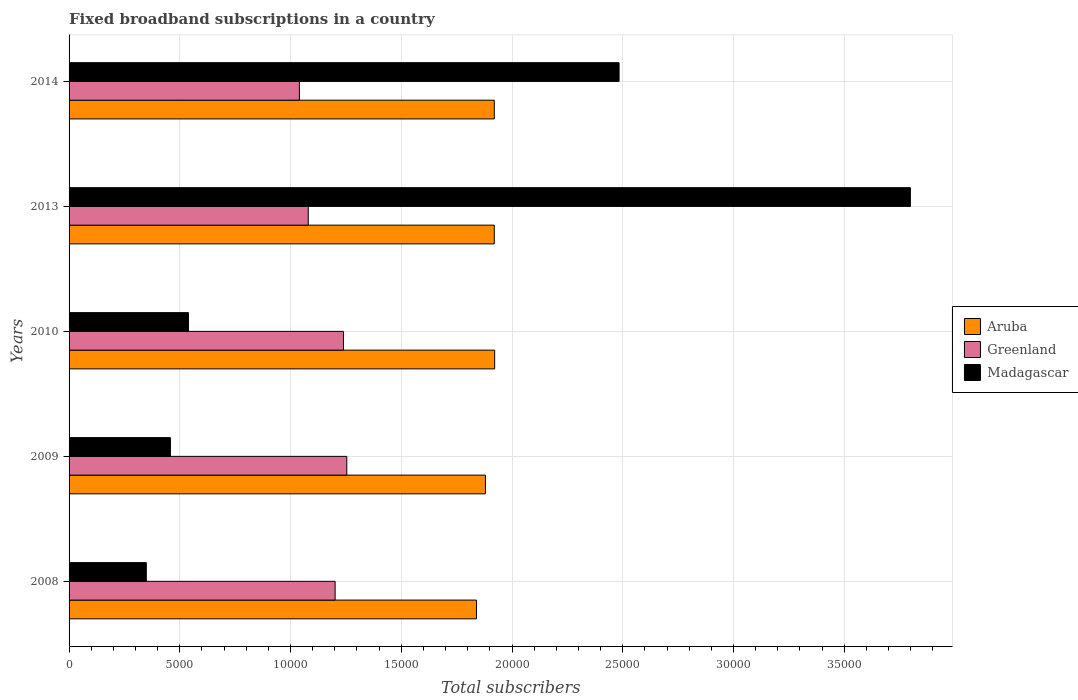Are the number of bars per tick equal to the number of legend labels?
Give a very brief answer. Yes. How many bars are there on the 5th tick from the top?
Provide a succinct answer. 3. How many bars are there on the 2nd tick from the bottom?
Your response must be concise. 3. In how many cases, is the number of bars for a given year not equal to the number of legend labels?
Keep it short and to the point. 0. What is the number of broadband subscriptions in Greenland in 2013?
Offer a very short reply. 1.08e+04. Across all years, what is the maximum number of broadband subscriptions in Madagascar?
Ensure brevity in your answer.  3.80e+04. Across all years, what is the minimum number of broadband subscriptions in Greenland?
Make the answer very short. 1.04e+04. In which year was the number of broadband subscriptions in Greenland maximum?
Your response must be concise. 2009. What is the total number of broadband subscriptions in Greenland in the graph?
Offer a very short reply. 5.81e+04. What is the difference between the number of broadband subscriptions in Madagascar in 2008 and that in 2014?
Your response must be concise. -2.13e+04. What is the difference between the number of broadband subscriptions in Greenland in 2009 and the number of broadband subscriptions in Aruba in 2013?
Offer a very short reply. -6660. What is the average number of broadband subscriptions in Madagascar per year?
Provide a short and direct response. 1.53e+04. In the year 2010, what is the difference between the number of broadband subscriptions in Madagascar and number of broadband subscriptions in Aruba?
Give a very brief answer. -1.38e+04. In how many years, is the number of broadband subscriptions in Aruba greater than 15000 ?
Keep it short and to the point. 5. What is the ratio of the number of broadband subscriptions in Greenland in 2009 to that in 2010?
Offer a very short reply. 1.01. Is the number of broadband subscriptions in Aruba in 2008 less than that in 2013?
Your response must be concise. Yes. Is the difference between the number of broadband subscriptions in Madagascar in 2008 and 2009 greater than the difference between the number of broadband subscriptions in Aruba in 2008 and 2009?
Make the answer very short. No. What is the difference between the highest and the second highest number of broadband subscriptions in Aruba?
Your answer should be very brief. 17. What is the difference between the highest and the lowest number of broadband subscriptions in Greenland?
Give a very brief answer. 2140. In how many years, is the number of broadband subscriptions in Greenland greater than the average number of broadband subscriptions in Greenland taken over all years?
Ensure brevity in your answer.  3. What does the 3rd bar from the top in 2009 represents?
Give a very brief answer. Aruba. What does the 3rd bar from the bottom in 2008 represents?
Provide a succinct answer. Madagascar. How many bars are there?
Provide a short and direct response. 15. Are all the bars in the graph horizontal?
Provide a succinct answer. Yes. How many years are there in the graph?
Offer a terse response. 5. Are the values on the major ticks of X-axis written in scientific E-notation?
Make the answer very short. No. Does the graph contain any zero values?
Your response must be concise. No. How many legend labels are there?
Your answer should be very brief. 3. What is the title of the graph?
Ensure brevity in your answer.  Fixed broadband subscriptions in a country. Does "Moldova" appear as one of the legend labels in the graph?
Ensure brevity in your answer.  No. What is the label or title of the X-axis?
Make the answer very short. Total subscribers. What is the Total subscribers of Aruba in 2008?
Make the answer very short. 1.84e+04. What is the Total subscribers of Greenland in 2008?
Ensure brevity in your answer.  1.20e+04. What is the Total subscribers in Madagascar in 2008?
Your response must be concise. 3488. What is the Total subscribers in Aruba in 2009?
Ensure brevity in your answer.  1.88e+04. What is the Total subscribers in Greenland in 2009?
Offer a terse response. 1.25e+04. What is the Total subscribers in Madagascar in 2009?
Give a very brief answer. 4576. What is the Total subscribers in Aruba in 2010?
Provide a short and direct response. 1.92e+04. What is the Total subscribers of Greenland in 2010?
Make the answer very short. 1.24e+04. What is the Total subscribers of Madagascar in 2010?
Make the answer very short. 5391. What is the Total subscribers in Aruba in 2013?
Keep it short and to the point. 1.92e+04. What is the Total subscribers of Greenland in 2013?
Your response must be concise. 1.08e+04. What is the Total subscribers in Madagascar in 2013?
Your answer should be compact. 3.80e+04. What is the Total subscribers of Aruba in 2014?
Offer a terse response. 1.92e+04. What is the Total subscribers in Greenland in 2014?
Your answer should be very brief. 1.04e+04. What is the Total subscribers of Madagascar in 2014?
Your answer should be compact. 2.48e+04. Across all years, what is the maximum Total subscribers of Aruba?
Provide a succinct answer. 1.92e+04. Across all years, what is the maximum Total subscribers of Greenland?
Offer a terse response. 1.25e+04. Across all years, what is the maximum Total subscribers of Madagascar?
Offer a terse response. 3.80e+04. Across all years, what is the minimum Total subscribers in Aruba?
Give a very brief answer. 1.84e+04. Across all years, what is the minimum Total subscribers in Greenland?
Your response must be concise. 1.04e+04. Across all years, what is the minimum Total subscribers in Madagascar?
Ensure brevity in your answer.  3488. What is the total Total subscribers in Aruba in the graph?
Ensure brevity in your answer.  9.48e+04. What is the total Total subscribers of Greenland in the graph?
Offer a very short reply. 5.81e+04. What is the total Total subscribers of Madagascar in the graph?
Your answer should be very brief. 7.63e+04. What is the difference between the Total subscribers in Aruba in 2008 and that in 2009?
Make the answer very short. -404. What is the difference between the Total subscribers in Greenland in 2008 and that in 2009?
Keep it short and to the point. -527. What is the difference between the Total subscribers in Madagascar in 2008 and that in 2009?
Make the answer very short. -1088. What is the difference between the Total subscribers of Aruba in 2008 and that in 2010?
Your answer should be very brief. -821. What is the difference between the Total subscribers in Greenland in 2008 and that in 2010?
Keep it short and to the point. -377. What is the difference between the Total subscribers of Madagascar in 2008 and that in 2010?
Your response must be concise. -1903. What is the difference between the Total subscribers in Aruba in 2008 and that in 2013?
Give a very brief answer. -804. What is the difference between the Total subscribers in Greenland in 2008 and that in 2013?
Offer a terse response. 1213. What is the difference between the Total subscribers in Madagascar in 2008 and that in 2013?
Provide a short and direct response. -3.45e+04. What is the difference between the Total subscribers in Aruba in 2008 and that in 2014?
Your answer should be compact. -804. What is the difference between the Total subscribers of Greenland in 2008 and that in 2014?
Provide a short and direct response. 1613. What is the difference between the Total subscribers of Madagascar in 2008 and that in 2014?
Provide a short and direct response. -2.13e+04. What is the difference between the Total subscribers in Aruba in 2009 and that in 2010?
Keep it short and to the point. -417. What is the difference between the Total subscribers in Greenland in 2009 and that in 2010?
Provide a short and direct response. 150. What is the difference between the Total subscribers of Madagascar in 2009 and that in 2010?
Make the answer very short. -815. What is the difference between the Total subscribers of Aruba in 2009 and that in 2013?
Your answer should be compact. -400. What is the difference between the Total subscribers of Greenland in 2009 and that in 2013?
Your response must be concise. 1740. What is the difference between the Total subscribers in Madagascar in 2009 and that in 2013?
Your response must be concise. -3.34e+04. What is the difference between the Total subscribers of Aruba in 2009 and that in 2014?
Give a very brief answer. -400. What is the difference between the Total subscribers in Greenland in 2009 and that in 2014?
Your answer should be compact. 2140. What is the difference between the Total subscribers of Madagascar in 2009 and that in 2014?
Make the answer very short. -2.03e+04. What is the difference between the Total subscribers in Greenland in 2010 and that in 2013?
Ensure brevity in your answer.  1590. What is the difference between the Total subscribers of Madagascar in 2010 and that in 2013?
Make the answer very short. -3.26e+04. What is the difference between the Total subscribers in Aruba in 2010 and that in 2014?
Offer a very short reply. 17. What is the difference between the Total subscribers of Greenland in 2010 and that in 2014?
Your response must be concise. 1990. What is the difference between the Total subscribers in Madagascar in 2010 and that in 2014?
Ensure brevity in your answer.  -1.94e+04. What is the difference between the Total subscribers of Aruba in 2013 and that in 2014?
Offer a terse response. 0. What is the difference between the Total subscribers of Madagascar in 2013 and that in 2014?
Your answer should be very brief. 1.32e+04. What is the difference between the Total subscribers of Aruba in 2008 and the Total subscribers of Greenland in 2009?
Provide a short and direct response. 5856. What is the difference between the Total subscribers in Aruba in 2008 and the Total subscribers in Madagascar in 2009?
Make the answer very short. 1.38e+04. What is the difference between the Total subscribers of Greenland in 2008 and the Total subscribers of Madagascar in 2009?
Make the answer very short. 7437. What is the difference between the Total subscribers of Aruba in 2008 and the Total subscribers of Greenland in 2010?
Ensure brevity in your answer.  6006. What is the difference between the Total subscribers in Aruba in 2008 and the Total subscribers in Madagascar in 2010?
Ensure brevity in your answer.  1.30e+04. What is the difference between the Total subscribers of Greenland in 2008 and the Total subscribers of Madagascar in 2010?
Provide a succinct answer. 6622. What is the difference between the Total subscribers in Aruba in 2008 and the Total subscribers in Greenland in 2013?
Offer a terse response. 7596. What is the difference between the Total subscribers of Aruba in 2008 and the Total subscribers of Madagascar in 2013?
Provide a short and direct response. -1.96e+04. What is the difference between the Total subscribers in Greenland in 2008 and the Total subscribers in Madagascar in 2013?
Ensure brevity in your answer.  -2.60e+04. What is the difference between the Total subscribers of Aruba in 2008 and the Total subscribers of Greenland in 2014?
Keep it short and to the point. 7996. What is the difference between the Total subscribers of Aruba in 2008 and the Total subscribers of Madagascar in 2014?
Your answer should be compact. -6439. What is the difference between the Total subscribers of Greenland in 2008 and the Total subscribers of Madagascar in 2014?
Ensure brevity in your answer.  -1.28e+04. What is the difference between the Total subscribers in Aruba in 2009 and the Total subscribers in Greenland in 2010?
Make the answer very short. 6410. What is the difference between the Total subscribers of Aruba in 2009 and the Total subscribers of Madagascar in 2010?
Your response must be concise. 1.34e+04. What is the difference between the Total subscribers in Greenland in 2009 and the Total subscribers in Madagascar in 2010?
Your answer should be compact. 7149. What is the difference between the Total subscribers in Aruba in 2009 and the Total subscribers in Greenland in 2013?
Keep it short and to the point. 8000. What is the difference between the Total subscribers of Aruba in 2009 and the Total subscribers of Madagascar in 2013?
Ensure brevity in your answer.  -1.92e+04. What is the difference between the Total subscribers of Greenland in 2009 and the Total subscribers of Madagascar in 2013?
Ensure brevity in your answer.  -2.54e+04. What is the difference between the Total subscribers of Aruba in 2009 and the Total subscribers of Greenland in 2014?
Provide a succinct answer. 8400. What is the difference between the Total subscribers in Aruba in 2009 and the Total subscribers in Madagascar in 2014?
Make the answer very short. -6035. What is the difference between the Total subscribers of Greenland in 2009 and the Total subscribers of Madagascar in 2014?
Offer a terse response. -1.23e+04. What is the difference between the Total subscribers in Aruba in 2010 and the Total subscribers in Greenland in 2013?
Provide a short and direct response. 8417. What is the difference between the Total subscribers of Aruba in 2010 and the Total subscribers of Madagascar in 2013?
Offer a terse response. -1.88e+04. What is the difference between the Total subscribers in Greenland in 2010 and the Total subscribers in Madagascar in 2013?
Make the answer very short. -2.56e+04. What is the difference between the Total subscribers of Aruba in 2010 and the Total subscribers of Greenland in 2014?
Offer a very short reply. 8817. What is the difference between the Total subscribers in Aruba in 2010 and the Total subscribers in Madagascar in 2014?
Offer a terse response. -5618. What is the difference between the Total subscribers of Greenland in 2010 and the Total subscribers of Madagascar in 2014?
Offer a very short reply. -1.24e+04. What is the difference between the Total subscribers in Aruba in 2013 and the Total subscribers in Greenland in 2014?
Your answer should be very brief. 8800. What is the difference between the Total subscribers of Aruba in 2013 and the Total subscribers of Madagascar in 2014?
Your answer should be compact. -5635. What is the difference between the Total subscribers in Greenland in 2013 and the Total subscribers in Madagascar in 2014?
Make the answer very short. -1.40e+04. What is the average Total subscribers of Aruba per year?
Your answer should be very brief. 1.90e+04. What is the average Total subscribers of Greenland per year?
Ensure brevity in your answer.  1.16e+04. What is the average Total subscribers in Madagascar per year?
Offer a very short reply. 1.53e+04. In the year 2008, what is the difference between the Total subscribers of Aruba and Total subscribers of Greenland?
Provide a succinct answer. 6383. In the year 2008, what is the difference between the Total subscribers of Aruba and Total subscribers of Madagascar?
Your response must be concise. 1.49e+04. In the year 2008, what is the difference between the Total subscribers in Greenland and Total subscribers in Madagascar?
Provide a succinct answer. 8525. In the year 2009, what is the difference between the Total subscribers of Aruba and Total subscribers of Greenland?
Your answer should be compact. 6260. In the year 2009, what is the difference between the Total subscribers in Aruba and Total subscribers in Madagascar?
Make the answer very short. 1.42e+04. In the year 2009, what is the difference between the Total subscribers of Greenland and Total subscribers of Madagascar?
Offer a terse response. 7964. In the year 2010, what is the difference between the Total subscribers in Aruba and Total subscribers in Greenland?
Make the answer very short. 6827. In the year 2010, what is the difference between the Total subscribers of Aruba and Total subscribers of Madagascar?
Ensure brevity in your answer.  1.38e+04. In the year 2010, what is the difference between the Total subscribers in Greenland and Total subscribers in Madagascar?
Your answer should be very brief. 6999. In the year 2013, what is the difference between the Total subscribers in Aruba and Total subscribers in Greenland?
Provide a succinct answer. 8400. In the year 2013, what is the difference between the Total subscribers of Aruba and Total subscribers of Madagascar?
Ensure brevity in your answer.  -1.88e+04. In the year 2013, what is the difference between the Total subscribers in Greenland and Total subscribers in Madagascar?
Give a very brief answer. -2.72e+04. In the year 2014, what is the difference between the Total subscribers in Aruba and Total subscribers in Greenland?
Offer a very short reply. 8800. In the year 2014, what is the difference between the Total subscribers of Aruba and Total subscribers of Madagascar?
Offer a very short reply. -5635. In the year 2014, what is the difference between the Total subscribers of Greenland and Total subscribers of Madagascar?
Provide a short and direct response. -1.44e+04. What is the ratio of the Total subscribers in Aruba in 2008 to that in 2009?
Make the answer very short. 0.98. What is the ratio of the Total subscribers of Greenland in 2008 to that in 2009?
Your answer should be compact. 0.96. What is the ratio of the Total subscribers in Madagascar in 2008 to that in 2009?
Make the answer very short. 0.76. What is the ratio of the Total subscribers of Aruba in 2008 to that in 2010?
Make the answer very short. 0.96. What is the ratio of the Total subscribers in Greenland in 2008 to that in 2010?
Your answer should be very brief. 0.97. What is the ratio of the Total subscribers of Madagascar in 2008 to that in 2010?
Your response must be concise. 0.65. What is the ratio of the Total subscribers of Aruba in 2008 to that in 2013?
Provide a succinct answer. 0.96. What is the ratio of the Total subscribers in Greenland in 2008 to that in 2013?
Offer a terse response. 1.11. What is the ratio of the Total subscribers of Madagascar in 2008 to that in 2013?
Offer a terse response. 0.09. What is the ratio of the Total subscribers in Aruba in 2008 to that in 2014?
Make the answer very short. 0.96. What is the ratio of the Total subscribers in Greenland in 2008 to that in 2014?
Offer a terse response. 1.16. What is the ratio of the Total subscribers in Madagascar in 2008 to that in 2014?
Offer a very short reply. 0.14. What is the ratio of the Total subscribers in Aruba in 2009 to that in 2010?
Keep it short and to the point. 0.98. What is the ratio of the Total subscribers in Greenland in 2009 to that in 2010?
Offer a very short reply. 1.01. What is the ratio of the Total subscribers of Madagascar in 2009 to that in 2010?
Ensure brevity in your answer.  0.85. What is the ratio of the Total subscribers in Aruba in 2009 to that in 2013?
Your answer should be very brief. 0.98. What is the ratio of the Total subscribers of Greenland in 2009 to that in 2013?
Make the answer very short. 1.16. What is the ratio of the Total subscribers of Madagascar in 2009 to that in 2013?
Offer a terse response. 0.12. What is the ratio of the Total subscribers in Aruba in 2009 to that in 2014?
Keep it short and to the point. 0.98. What is the ratio of the Total subscribers of Greenland in 2009 to that in 2014?
Provide a short and direct response. 1.21. What is the ratio of the Total subscribers in Madagascar in 2009 to that in 2014?
Keep it short and to the point. 0.18. What is the ratio of the Total subscribers in Aruba in 2010 to that in 2013?
Give a very brief answer. 1. What is the ratio of the Total subscribers in Greenland in 2010 to that in 2013?
Give a very brief answer. 1.15. What is the ratio of the Total subscribers in Madagascar in 2010 to that in 2013?
Your answer should be very brief. 0.14. What is the ratio of the Total subscribers in Greenland in 2010 to that in 2014?
Give a very brief answer. 1.19. What is the ratio of the Total subscribers of Madagascar in 2010 to that in 2014?
Your response must be concise. 0.22. What is the ratio of the Total subscribers in Madagascar in 2013 to that in 2014?
Offer a terse response. 1.53. What is the difference between the highest and the second highest Total subscribers in Greenland?
Make the answer very short. 150. What is the difference between the highest and the second highest Total subscribers of Madagascar?
Ensure brevity in your answer.  1.32e+04. What is the difference between the highest and the lowest Total subscribers of Aruba?
Provide a short and direct response. 821. What is the difference between the highest and the lowest Total subscribers in Greenland?
Your answer should be compact. 2140. What is the difference between the highest and the lowest Total subscribers in Madagascar?
Your answer should be very brief. 3.45e+04. 